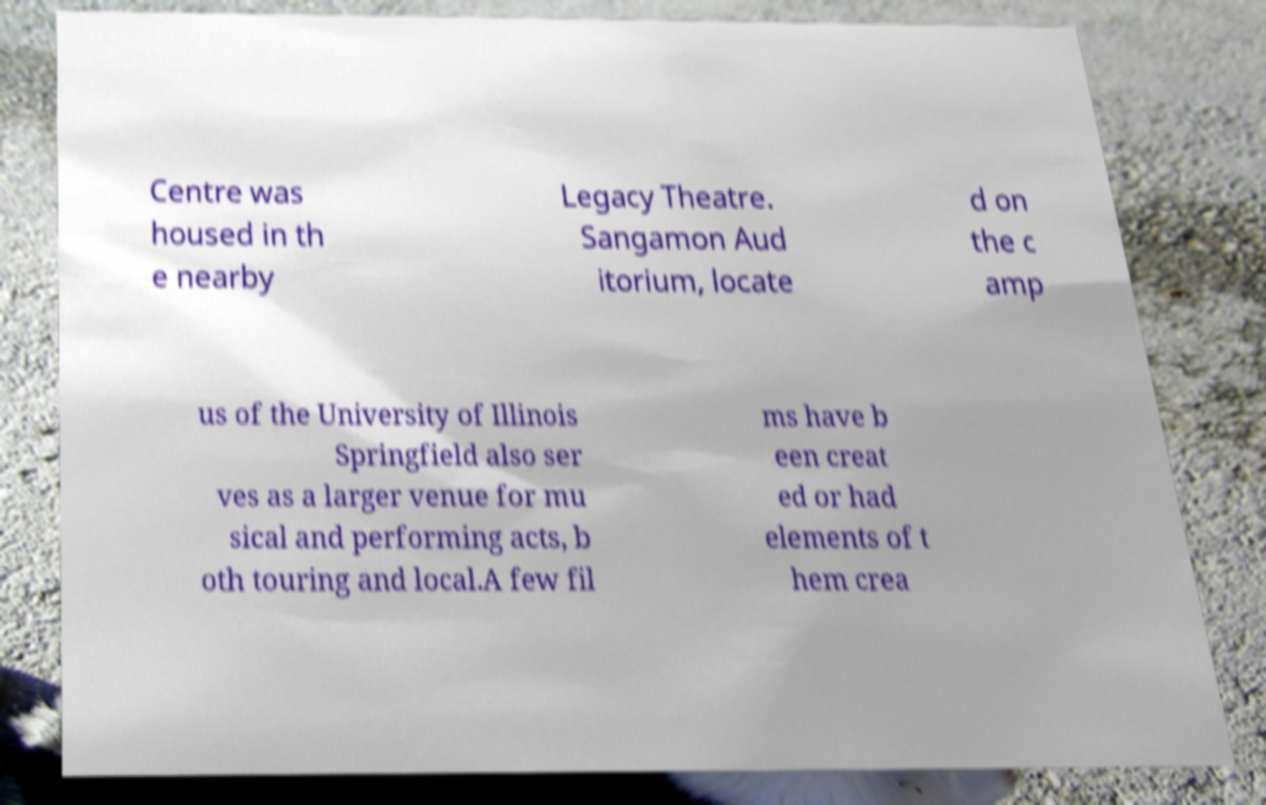There's text embedded in this image that I need extracted. Can you transcribe it verbatim? Centre was housed in th e nearby Legacy Theatre. Sangamon Aud itorium, locate d on the c amp us of the University of Illinois Springfield also ser ves as a larger venue for mu sical and performing acts, b oth touring and local.A few fil ms have b een creat ed or had elements of t hem crea 